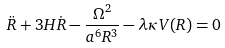Convert formula to latex. <formula><loc_0><loc_0><loc_500><loc_500>\ddot { R } + 3 H \dot { R } - \frac { \Omega ^ { 2 } } { a ^ { 6 } R ^ { 3 } } - \lambda \kappa V ( R ) = 0</formula> 